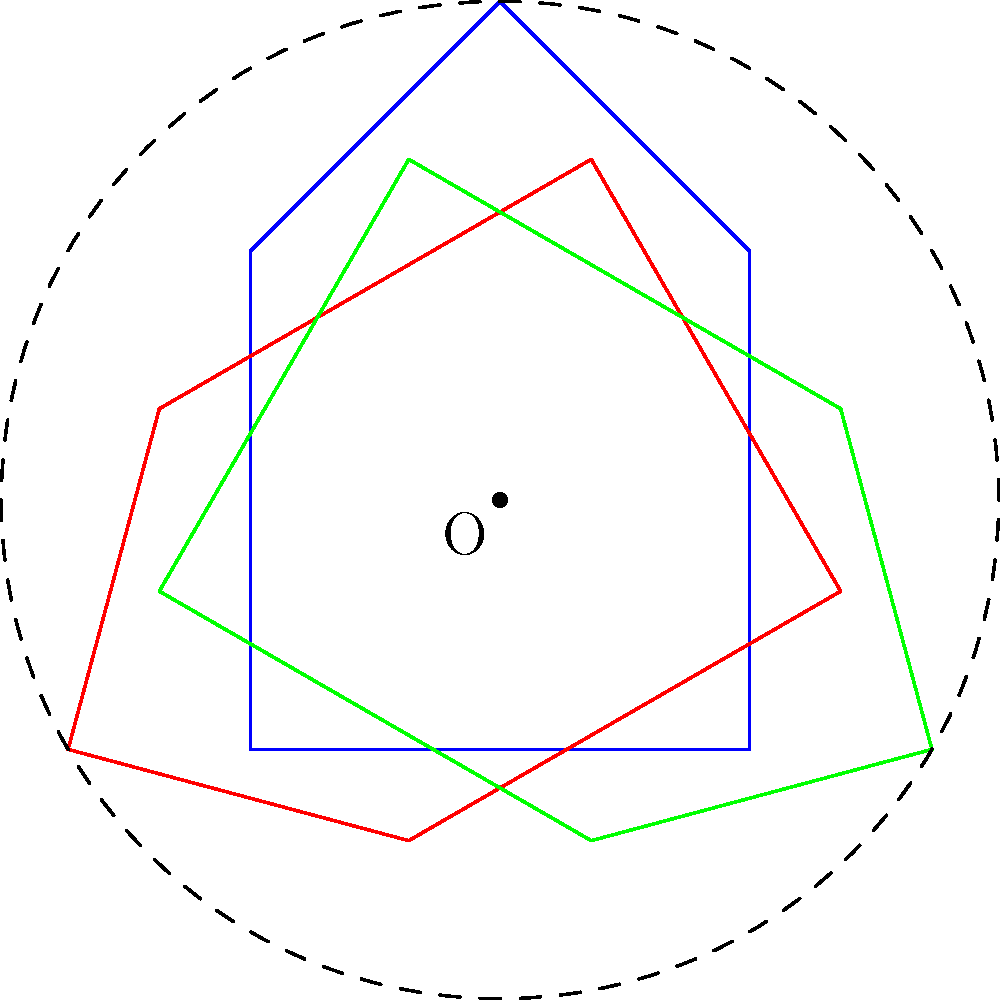In the diagram, three human rights symbols are rotated around a central point O. The blue symbol is in its original position. What is the angle of rotation between each consecutive symbol, and how many degrees would you need to rotate the blue symbol clockwise to align it with the green symbol? To solve this problem, let's follow these steps:

1. Observe the symmetry: There are three identical symbols arranged around a central point.

2. Calculate the angle between symbols:
   - A full rotation is 360°
   - With 3 equally spaced symbols, we divide 360° by 3
   - $\frac{360°}{3} = 120°$

3. Identify the rotation direction:
   - The symbols appear to be rotated counterclockwise from blue to red to green

4. Calculate the rotation from blue to green:
   - This requires two 120° rotations counterclockwise
   - Alternatively, it's one 240° rotation counterclockwise

5. Convert to clockwise rotation:
   - A 240° counterclockwise rotation is equivalent to a 120° clockwise rotation
   - This is because $360° - 240° = 120°$

Therefore, the angle between each consecutive symbol is 120°, and you would need to rotate the blue symbol 120° clockwise to align it with the green symbol.
Answer: 120° 